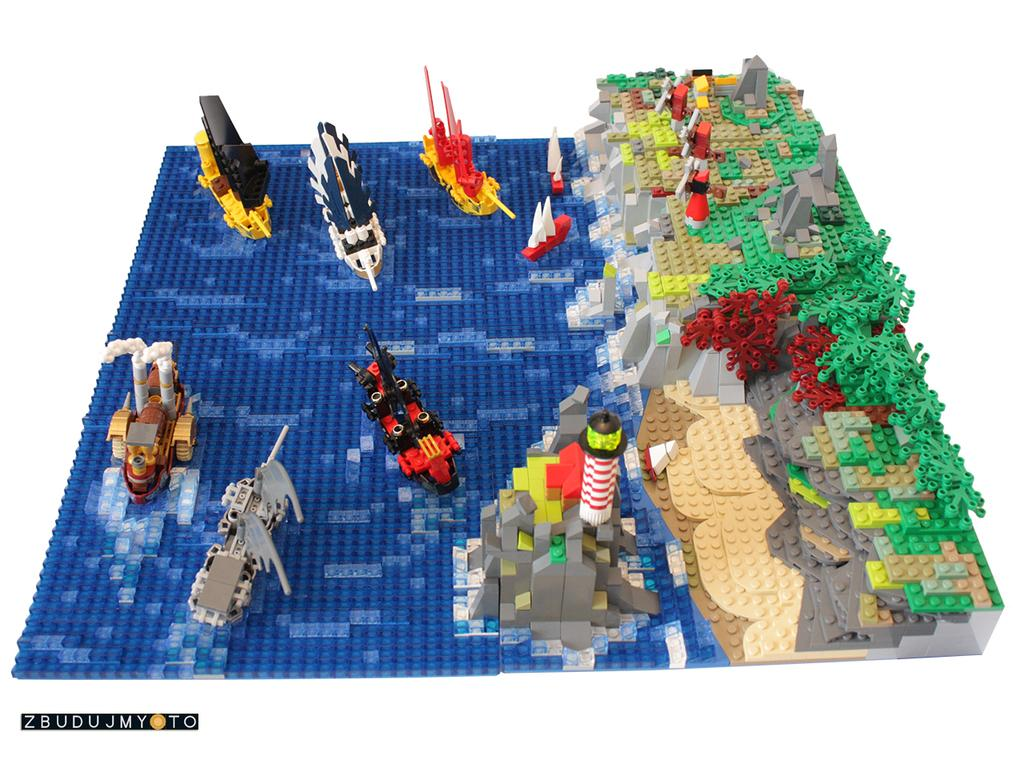What type of toy is visible in the image? There is a construction set toy in the image. What type of attraction is the fireman attending in the image? There is no fireman or attraction present in the image; it only features a construction set toy. 